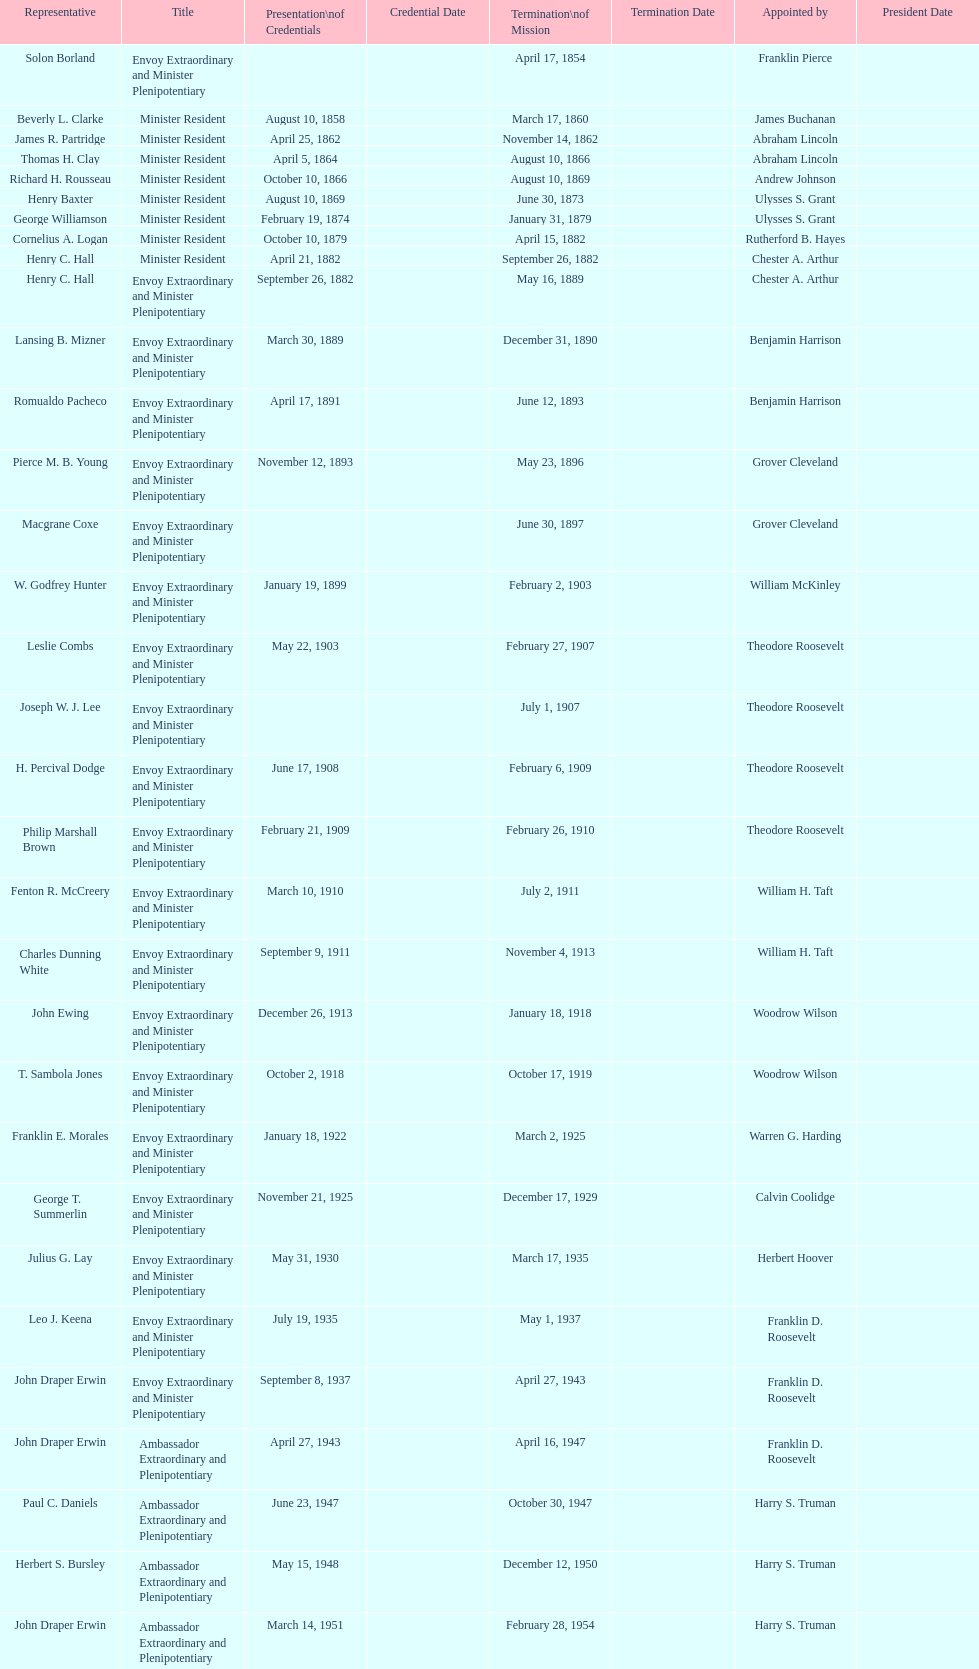Which minister resident had the shortest appointment? Henry C. Hall. 